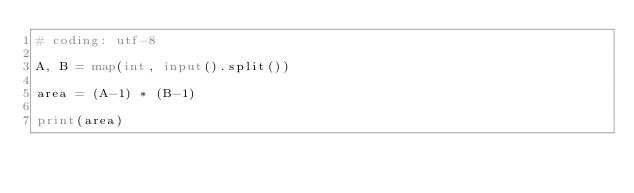Convert code to text. <code><loc_0><loc_0><loc_500><loc_500><_Python_># coding: utf-8

A, B = map(int, input().split())

area = (A-1) * (B-1)

print(area)</code> 